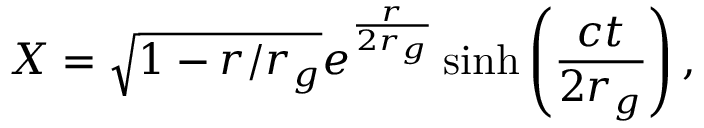<formula> <loc_0><loc_0><loc_500><loc_500>X = \sqrt { 1 - r / r _ { g } } e ^ { \frac { r } { 2 r _ { g } } } \sinh \left ( \frac { c t } { 2 r _ { g } } \right ) ,</formula> 